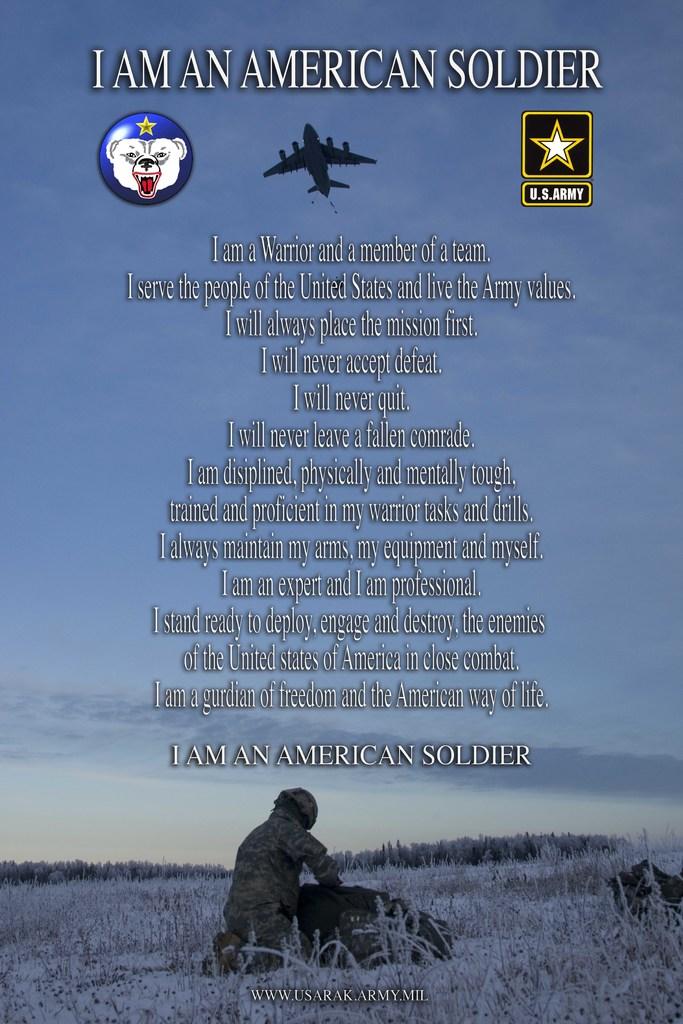What kind of soldier are they?
Provide a short and direct response. American. 